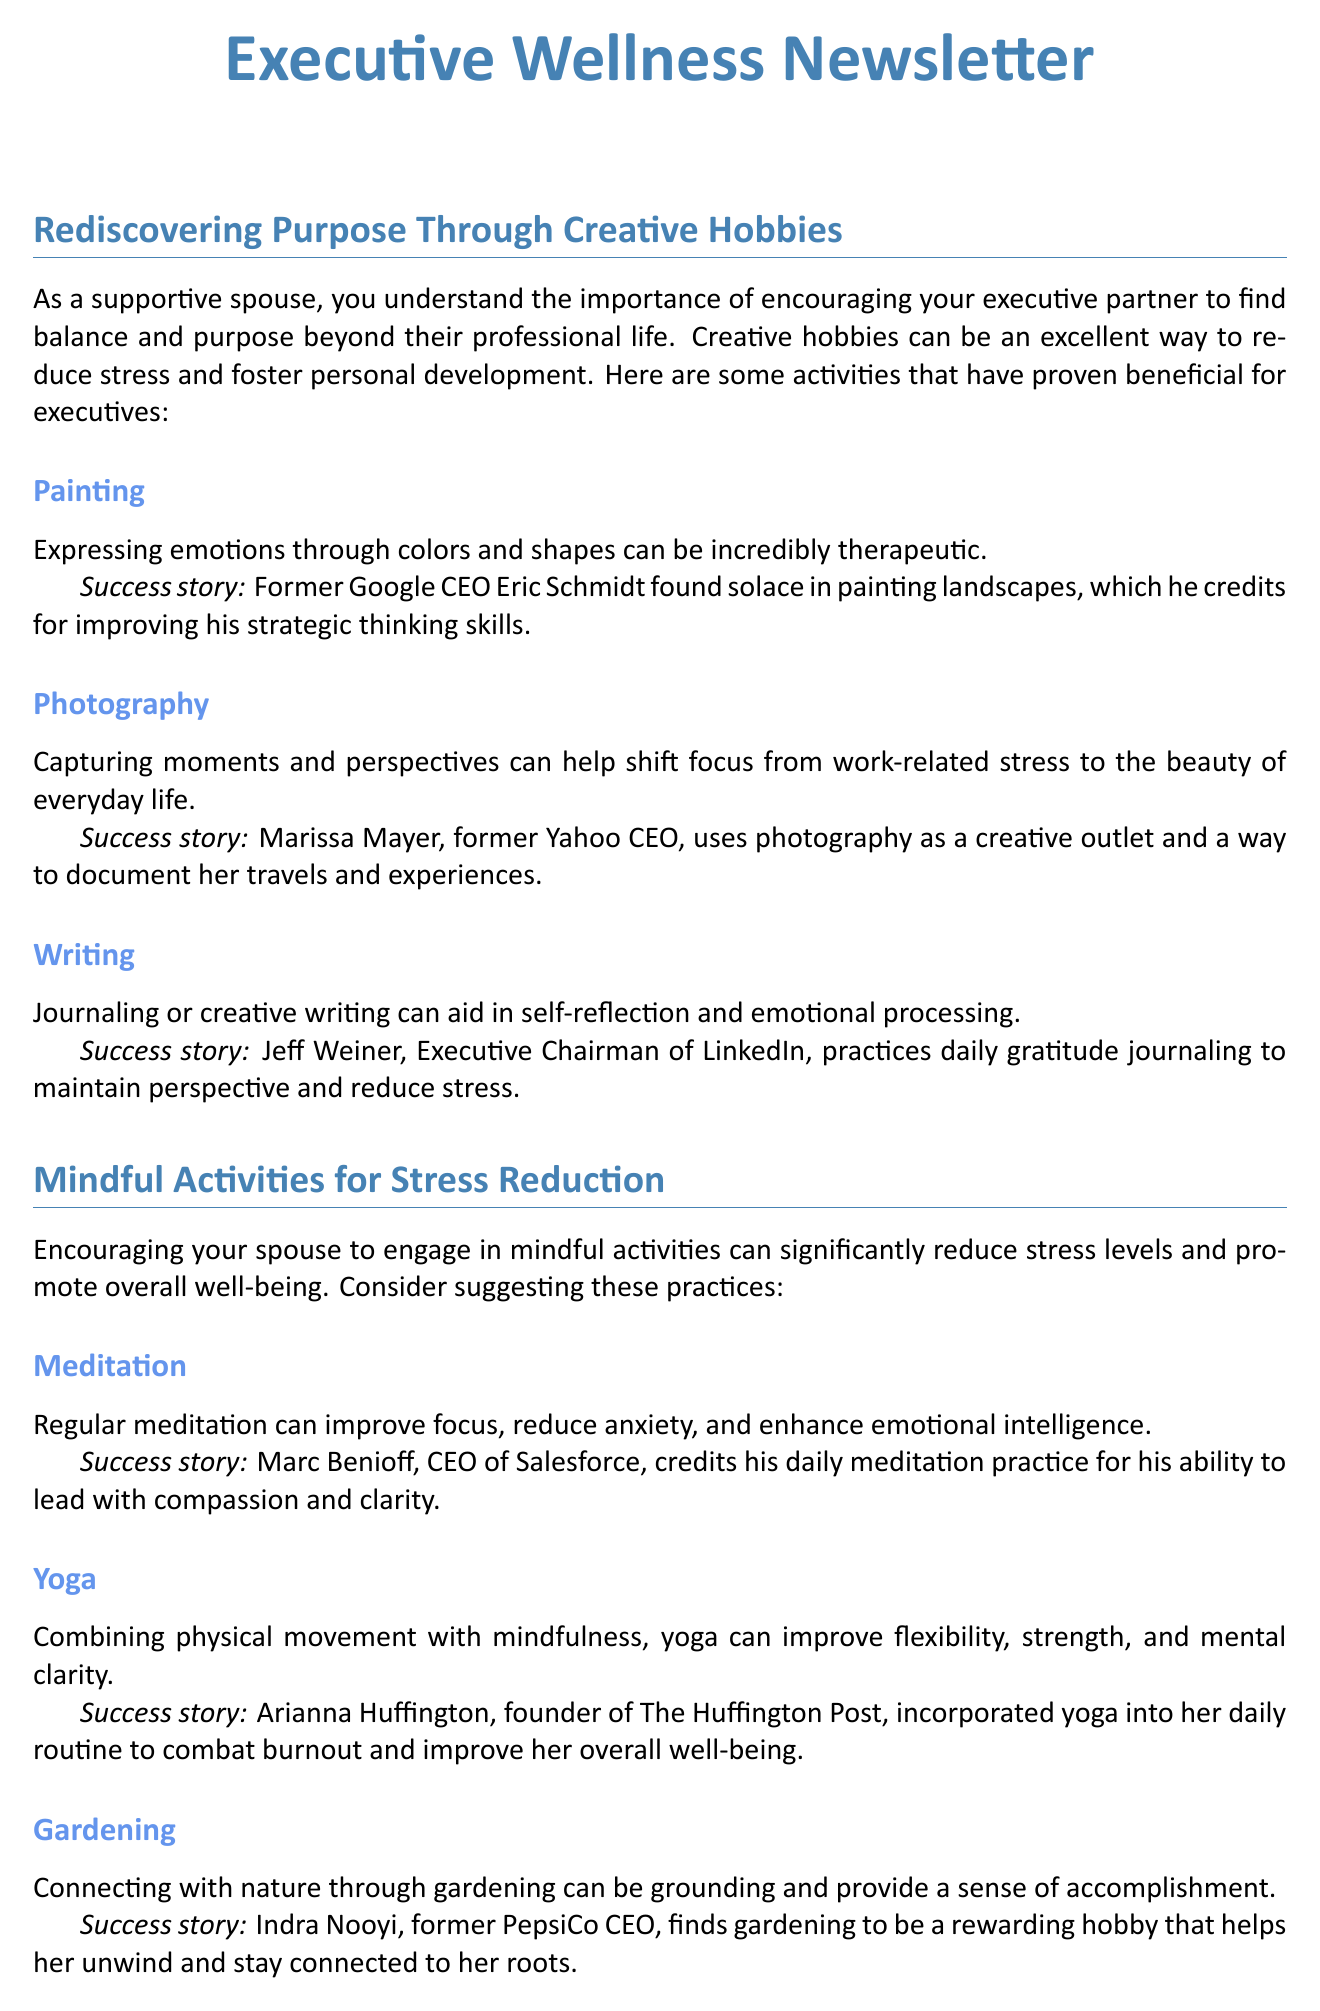What are some creative hobbies mentioned? The document lists several creative hobbies that executives can pursue, including painting, photography, and writing.
Answer: Painting, photography, writing Who is cited for using meditation as a leadership tool? Marc Benioff, CEO of Salesforce, is mentioned in relation to meditation.
Answer: Marc Benioff What is one way gardening helps executives? The document states that gardening connects individuals with nature, providing grounding and a sense of accomplishment.
Answer: Grounding and providing a sense of accomplishment Which CEO plays the ukulele to relax? Warren Buffett is noted for playing the ukulele.
Answer: Warren Buffett How many skill-building hobbies are highlighted? The document specifies three skill-building hobbies: learning a musical instrument, cooking, and foreign language learning.
Answer: Three What does the newsletter mainly promote? The newsletter primarily promotes engaging in creative hobbies and mindful activities for stress reduction and personal development.
Answer: Engaging in creative hobbies and mindful activities What is a suggested strategy for couples in the newsletter? One suggested strategy for couples is to set aside dedicated time for hobby exploration together.
Answer: Set aside dedicated time for hobby exploration together Which executive practices daily gratitude journaling? The document highlights Jeff Weiner for his daily gratitude journaling practice.
Answer: Jeff Weiner 